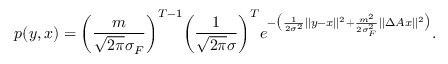<formula> <loc_0><loc_0><loc_500><loc_500>p ( y , x ) = \left ( \frac { m } { \sqrt { 2 \pi } \sigma _ { F } } \right ) ^ { T - 1 } \left ( \frac { 1 } { \sqrt { 2 \pi } \sigma } \right ) ^ { T } e ^ { - \left ( \frac { 1 } { 2 \sigma ^ { 2 } } | | y - x | | ^ { 2 } + \frac { m ^ { 2 } } { 2 \sigma _ { F } ^ { 2 } } | | \Delta A x | | ^ { 2 } \right ) } .</formula> 